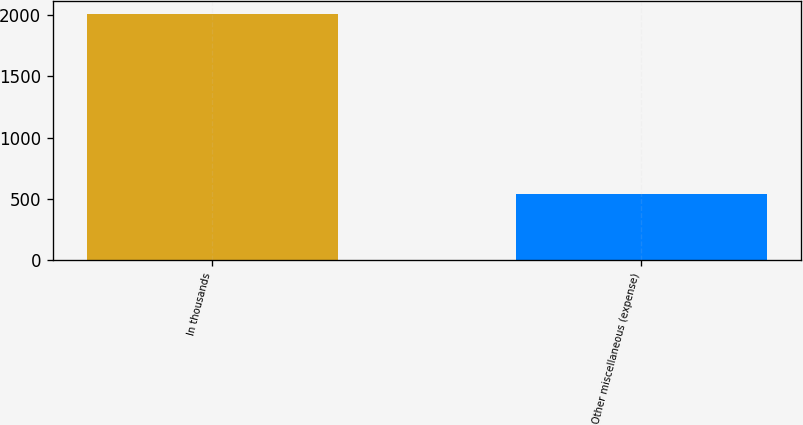Convert chart to OTSL. <chart><loc_0><loc_0><loc_500><loc_500><bar_chart><fcel>In thousands<fcel>Other miscellaneous (expense)<nl><fcel>2012<fcel>536<nl></chart> 